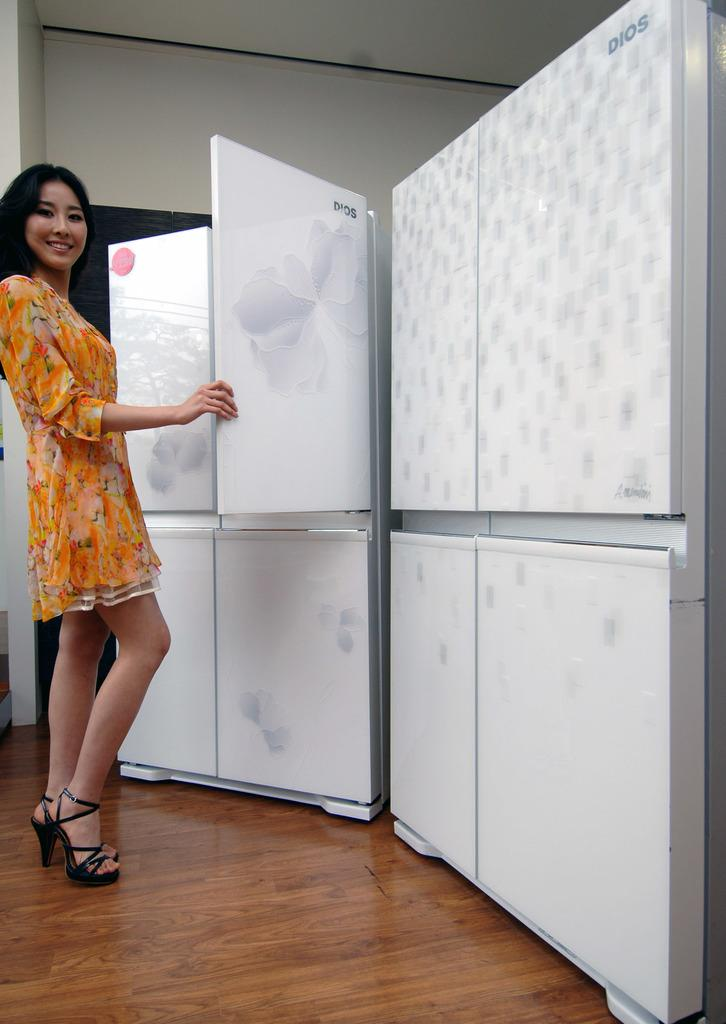<image>
Give a short and clear explanation of the subsequent image. A female model opening the door of a Dios fridge 